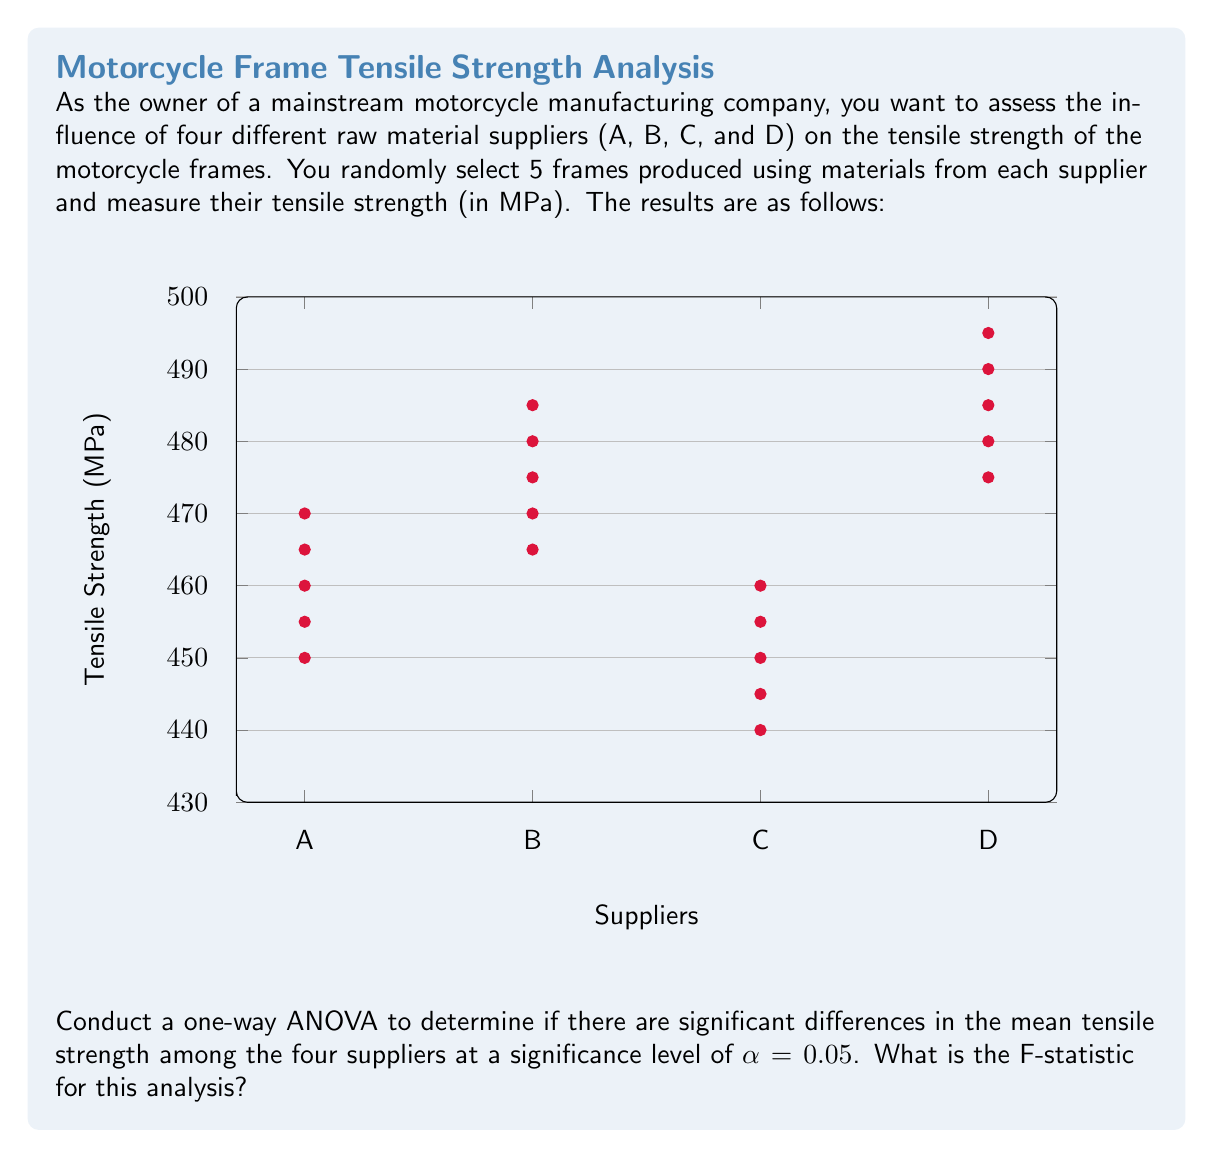Solve this math problem. To conduct a one-way ANOVA, we need to follow these steps:

1. Calculate the overall mean:
   $$\bar{X} = \frac{\sum_{i=1}^{k}\sum_{j=1}^{n}X_{ij}}{N}$$
   where k = 4 (number of groups), n = 5 (sample size per group), and N = kn = 20 (total sample size)

2. Calculate the Sum of Squares Total (SST):
   $$SST = \sum_{i=1}^{k}\sum_{j=1}^{n}(X_{ij} - \bar{X})^2$$

3. Calculate the Sum of Squares Between (SSB):
   $$SSB = n\sum_{i=1}^{k}(\bar{X_i} - \bar{X})^2$$
   where $\bar{X_i}$ is the mean of each group

4. Calculate the Sum of Squares Within (SSW):
   $$SSW = SST - SSB$$

5. Calculate the degrees of freedom:
   dfB = k - 1 = 3
   dfW = N - k = 16
   dfT = N - 1 = 19

6. Calculate the Mean Square Between (MSB) and Mean Square Within (MSW):
   $$MSB = \frac{SSB}{dfB}$$
   $$MSW = \frac{SSW}{dfW}$$

7. Calculate the F-statistic:
   $$F = \frac{MSB}{MSW}$$

Let's perform these calculations:

1. $\bar{X} = 467.25$

2. SST = 8,268.75

3. Group means:
   $\bar{X_A} = 460$
   $\bar{X_B} = 475$
   $\bar{X_C} = 450$
   $\bar{X_D} = 485$

   SSB = 5 * ((460 - 467.25)^2 + (475 - 467.25)^2 + (450 - 467.25)^2 + (485 - 467.25)^2)
   SSB = 7,218.75

4. SSW = SST - SSB = 8,268.75 - 7,218.75 = 1,050

5. dfB = 3, dfW = 16, dfT = 19

6. MSB = 7,218.75 / 3 = 2,406.25
   MSW = 1,050 / 16 = 65.625

7. F = 2,406.25 / 65.625 = 36.67

Therefore, the F-statistic for this analysis is 36.67.
Answer: 36.67 